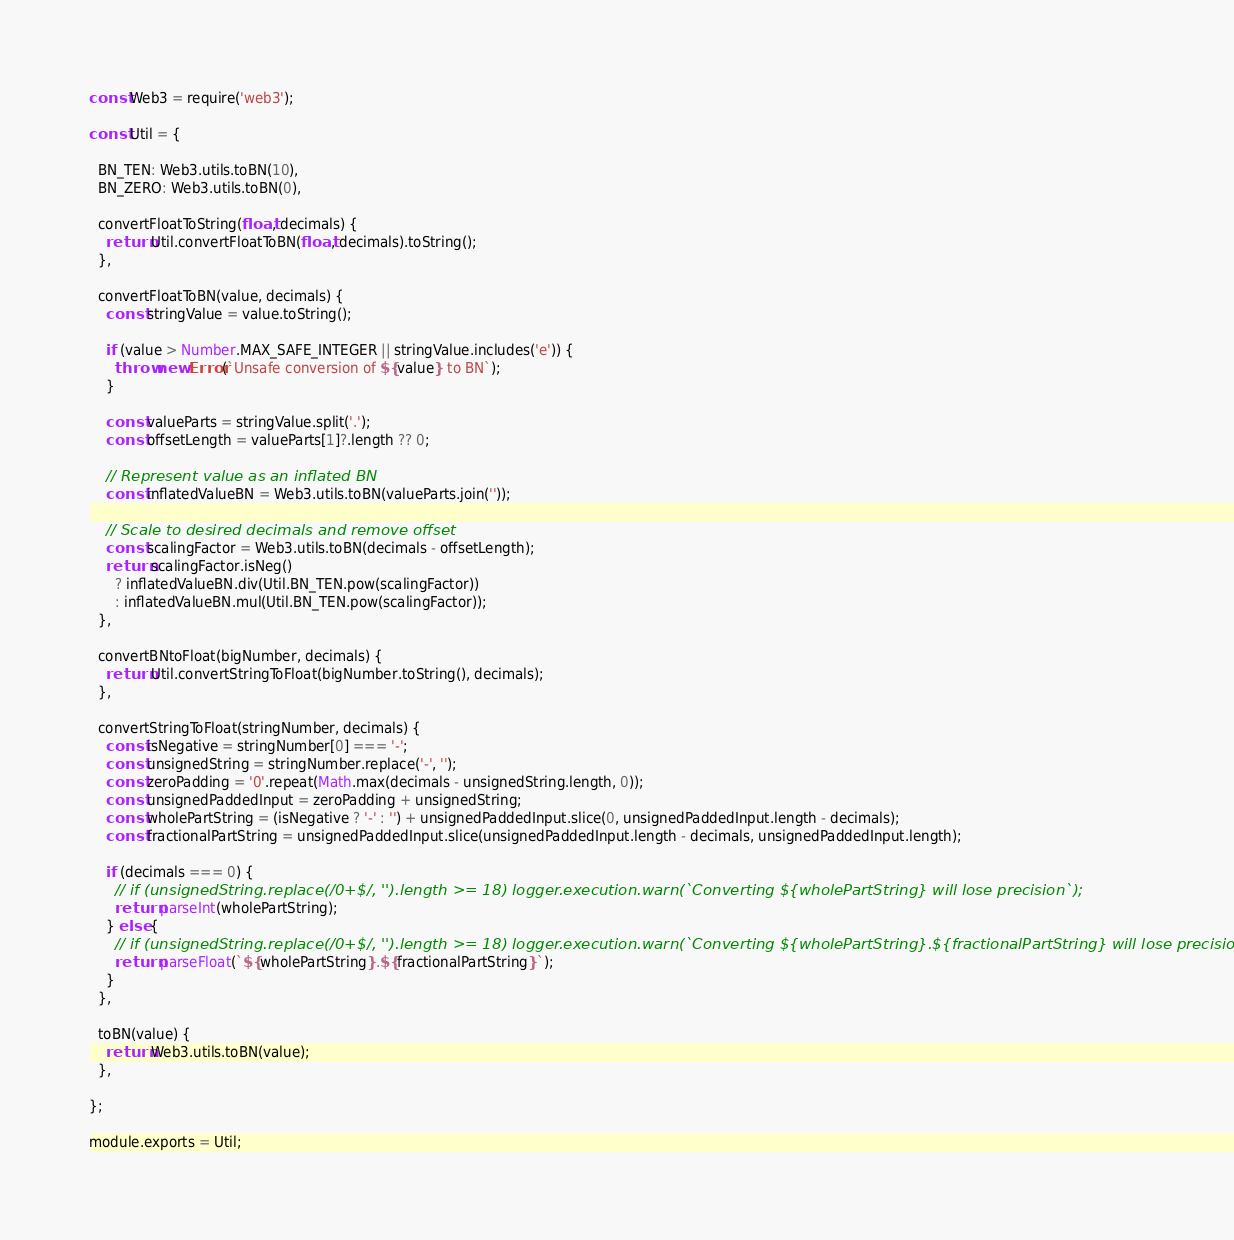Convert code to text. <code><loc_0><loc_0><loc_500><loc_500><_JavaScript_>const Web3 = require('web3');

const Util = {

  BN_TEN: Web3.utils.toBN(10),
  BN_ZERO: Web3.utils.toBN(0),

  convertFloatToString(float, decimals) {
    return Util.convertFloatToBN(float, decimals).toString();
  },

  convertFloatToBN(value, decimals) {
    const stringValue = value.toString();

    if (value > Number.MAX_SAFE_INTEGER || stringValue.includes('e')) {
      throw new Error(`Unsafe conversion of ${value} to BN`);
    }

    const valueParts = stringValue.split('.');
    const offsetLength = valueParts[1]?.length ?? 0;

    // Represent value as an inflated BN
    const inflatedValueBN = Web3.utils.toBN(valueParts.join(''));

    // Scale to desired decimals and remove offset
    const scalingFactor = Web3.utils.toBN(decimals - offsetLength);
    return scalingFactor.isNeg()
      ? inflatedValueBN.div(Util.BN_TEN.pow(scalingFactor))
      : inflatedValueBN.mul(Util.BN_TEN.pow(scalingFactor));
  },

  convertBNtoFloat(bigNumber, decimals) {
    return Util.convertStringToFloat(bigNumber.toString(), decimals);
  },

  convertStringToFloat(stringNumber, decimals) {
    const isNegative = stringNumber[0] === '-';
    const unsignedString = stringNumber.replace('-', '');
    const zeroPadding = '0'.repeat(Math.max(decimals - unsignedString.length, 0));
    const unsignedPaddedInput = zeroPadding + unsignedString;
    const wholePartString = (isNegative ? '-' : '') + unsignedPaddedInput.slice(0, unsignedPaddedInput.length - decimals);
    const fractionalPartString = unsignedPaddedInput.slice(unsignedPaddedInput.length - decimals, unsignedPaddedInput.length);

    if (decimals === 0) {
      // if (unsignedString.replace(/0+$/, '').length >= 18) logger.execution.warn(`Converting ${wholePartString} will lose precision`);
      return parseInt(wholePartString);
    } else {
      // if (unsignedString.replace(/0+$/, '').length >= 18) logger.execution.warn(`Converting ${wholePartString}.${fractionalPartString} will lose precision`);
      return parseFloat(`${wholePartString}.${fractionalPartString}`);
    }
  },

  toBN(value) {
    return Web3.utils.toBN(value);
  },

};

module.exports = Util;
</code> 